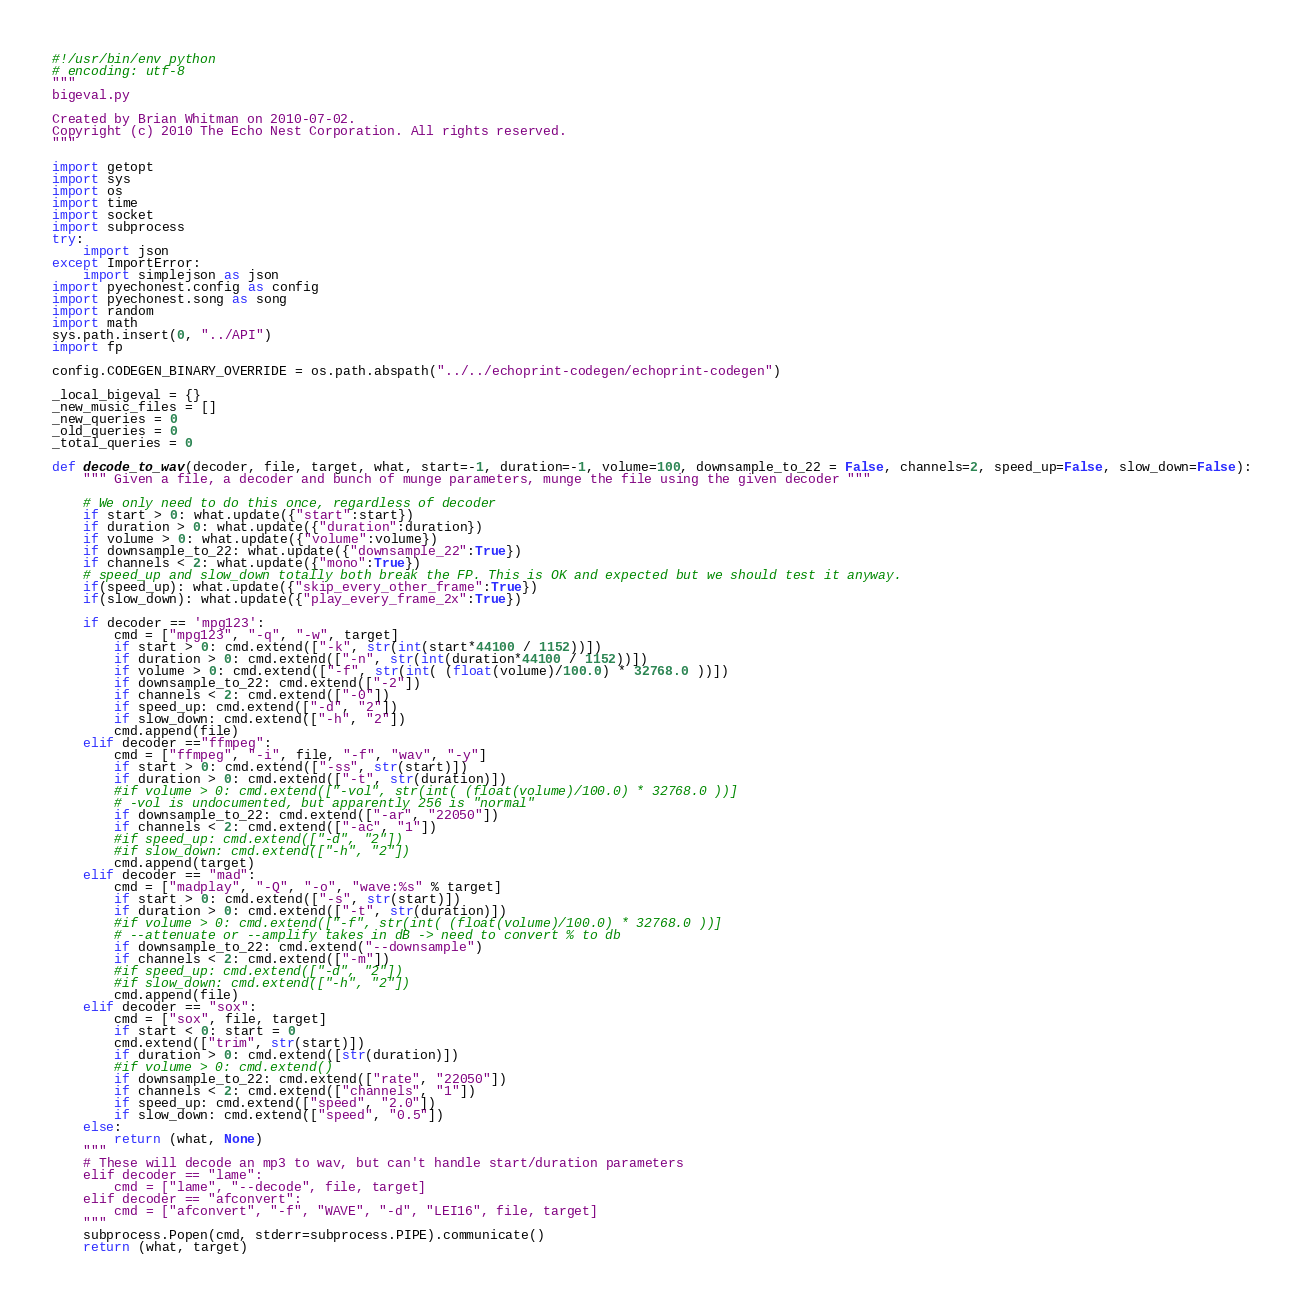Convert code to text. <code><loc_0><loc_0><loc_500><loc_500><_Python_>#!/usr/bin/env python
# encoding: utf-8
"""
bigeval.py

Created by Brian Whitman on 2010-07-02.
Copyright (c) 2010 The Echo Nest Corporation. All rights reserved.
"""

import getopt
import sys
import os
import time
import socket
import subprocess
try:
    import json
except ImportError:
    import simplejson as json
import pyechonest.config as config
import pyechonest.song as song
import random
import math
sys.path.insert(0, "../API")
import fp

config.CODEGEN_BINARY_OVERRIDE = os.path.abspath("../../echoprint-codegen/echoprint-codegen")

_local_bigeval = {}
_new_music_files = []
_new_queries = 0
_old_queries = 0
_total_queries = 0

def decode_to_wav(decoder, file, target, what, start=-1, duration=-1, volume=100, downsample_to_22 = False, channels=2, speed_up=False, slow_down=False):
    """ Given a file, a decoder and bunch of munge parameters, munge the file using the given decoder """

    # We only need to do this once, regardless of decoder
    if start > 0: what.update({"start":start})
    if duration > 0: what.update({"duration":duration})
    if volume > 0: what.update({"volume":volume})
    if downsample_to_22: what.update({"downsample_22":True})
    if channels < 2: what.update({"mono":True})
    # speed_up and slow_down totally both break the FP. This is OK and expected but we should test it anyway.
    if(speed_up): what.update({"skip_every_other_frame":True})
    if(slow_down): what.update({"play_every_frame_2x":True})

    if decoder == 'mpg123':
        cmd = ["mpg123", "-q", "-w", target]
        if start > 0: cmd.extend(["-k", str(int(start*44100 / 1152))])
        if duration > 0: cmd.extend(["-n", str(int(duration*44100 / 1152))])
        if volume > 0: cmd.extend(["-f", str(int( (float(volume)/100.0) * 32768.0 ))])
        if downsample_to_22: cmd.extend(["-2"])
        if channels < 2: cmd.extend(["-0"])
        if speed_up: cmd.extend(["-d", "2"])
        if slow_down: cmd.extend(["-h", "2"])
        cmd.append(file)
    elif decoder =="ffmpeg":
        cmd = ["ffmpeg", "-i", file, "-f", "wav", "-y"]
        if start > 0: cmd.extend(["-ss", str(start)])
        if duration > 0: cmd.extend(["-t", str(duration)])
        #if volume > 0: cmd.extend(["-vol", str(int( (float(volume)/100.0) * 32768.0 ))]
        # -vol is undocumented, but apparently 256 is "normal"
        if downsample_to_22: cmd.extend(["-ar", "22050"])
        if channels < 2: cmd.extend(["-ac", "1"])
        #if speed_up: cmd.extend(["-d", "2"])
        #if slow_down: cmd.extend(["-h", "2"])
        cmd.append(target)
    elif decoder == "mad":
        cmd = ["madplay", "-Q", "-o", "wave:%s" % target]
        if start > 0: cmd.extend(["-s", str(start)])
        if duration > 0: cmd.extend(["-t", str(duration)])
        #if volume > 0: cmd.extend(["-f", str(int( (float(volume)/100.0) * 32768.0 ))]
        # --attenuate or --amplify takes in dB -> need to convert % to db
        if downsample_to_22: cmd.extend("--downsample")
        if channels < 2: cmd.extend(["-m"])
        #if speed_up: cmd.extend(["-d", "2"])
        #if slow_down: cmd.extend(["-h", "2"])
        cmd.append(file)
    elif decoder == "sox":
        cmd = ["sox", file, target]
        if start < 0: start = 0
        cmd.extend(["trim", str(start)])
        if duration > 0: cmd.extend([str(duration)])
        #if volume > 0: cmd.extend()
        if downsample_to_22: cmd.extend(["rate", "22050"])
        if channels < 2: cmd.extend(["channels", "1"])
        if speed_up: cmd.extend(["speed", "2.0"])
        if slow_down: cmd.extend(["speed", "0.5"])
    else:
        return (what, None)
    """
    # These will decode an mp3 to wav, but can't handle start/duration parameters
    elif decoder == "lame":
        cmd = ["lame", "--decode", file, target]
    elif decoder == "afconvert":
        cmd = ["afconvert", "-f", "WAVE", "-d", "LEI16", file, target]
    """
    subprocess.Popen(cmd, stderr=subprocess.PIPE).communicate()
    return (what, target)
</code> 